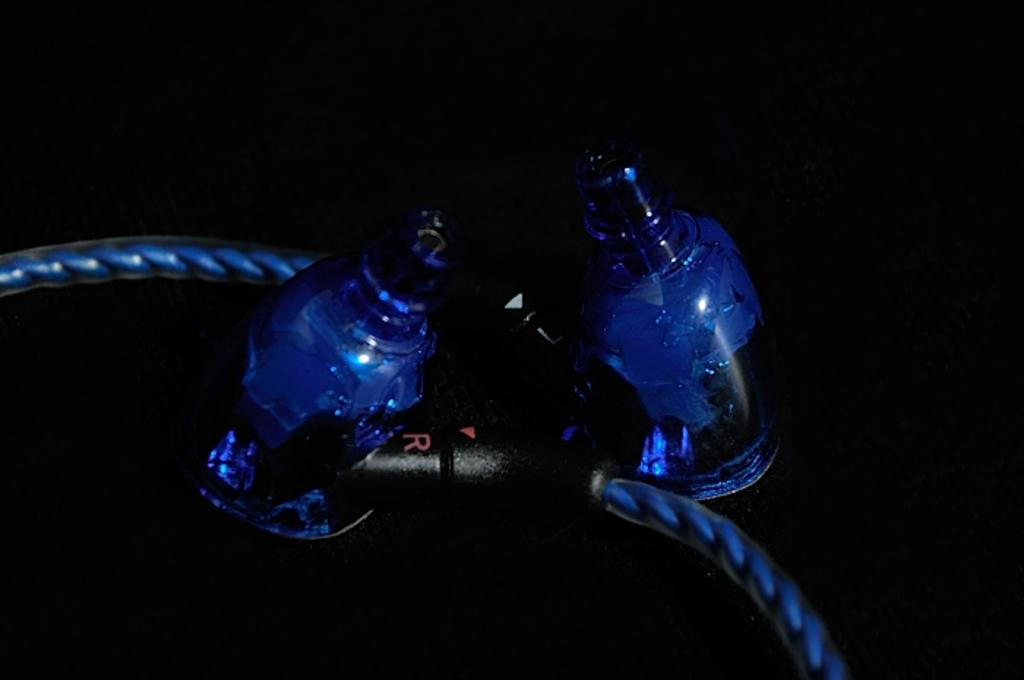How many glass bottles are visible in the image? There are two glass bottles in the image. What color are the caps on the glass bottles? The glass bottles have black caps. What color are the bodies of the glass bottles? The glass bottles have blue bodies. Is there anything connected to the glass bottles in the image? Yes, a cable is attached to the glass bottles. What type of haircut does the glass bottle on the left have in the image? The glass bottles do not have haircuts, as they are inanimate objects. 